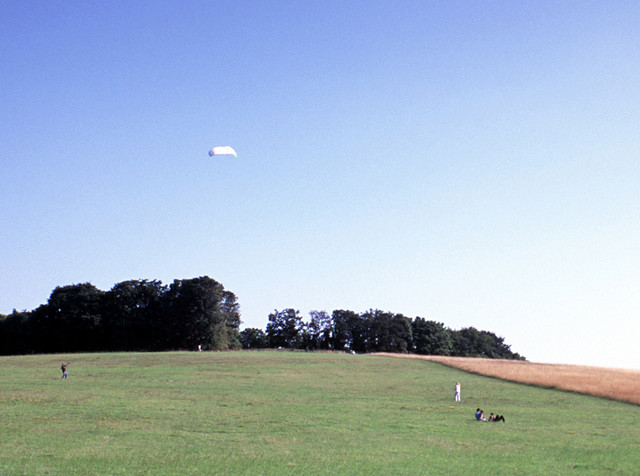What type of location is being visited?
A. swamp
B. ocean
C. field
D. forest
Answer with the option's letter from the given choices directly. C 